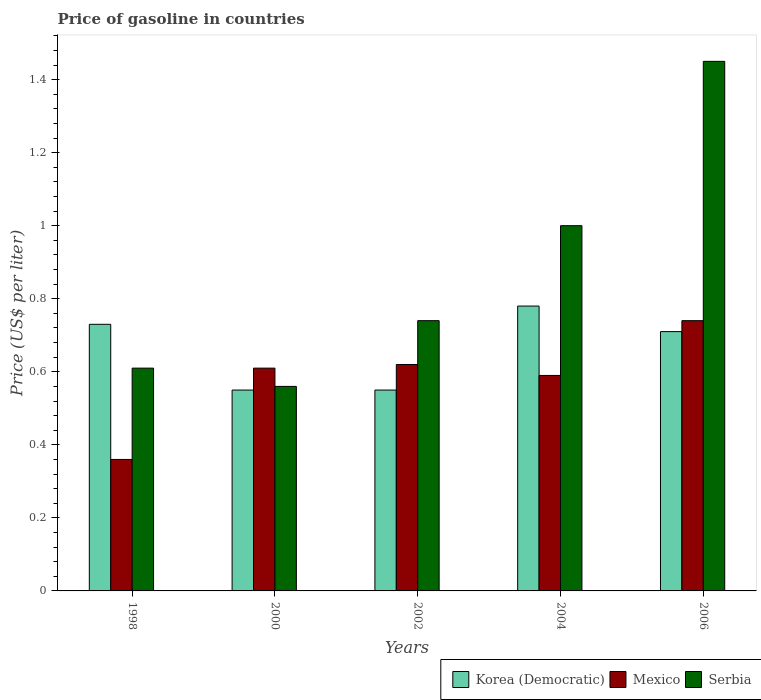How many groups of bars are there?
Make the answer very short. 5. Are the number of bars per tick equal to the number of legend labels?
Offer a terse response. Yes. Are the number of bars on each tick of the X-axis equal?
Provide a succinct answer. Yes. What is the price of gasoline in Mexico in 2002?
Give a very brief answer. 0.62. Across all years, what is the maximum price of gasoline in Korea (Democratic)?
Keep it short and to the point. 0.78. Across all years, what is the minimum price of gasoline in Serbia?
Provide a short and direct response. 0.56. In which year was the price of gasoline in Serbia minimum?
Provide a succinct answer. 2000. What is the total price of gasoline in Serbia in the graph?
Keep it short and to the point. 4.36. What is the difference between the price of gasoline in Mexico in 1998 and that in 2002?
Keep it short and to the point. -0.26. What is the difference between the price of gasoline in Mexico in 2006 and the price of gasoline in Korea (Democratic) in 2002?
Your response must be concise. 0.19. What is the average price of gasoline in Korea (Democratic) per year?
Provide a succinct answer. 0.66. In the year 2004, what is the difference between the price of gasoline in Korea (Democratic) and price of gasoline in Mexico?
Make the answer very short. 0.19. In how many years, is the price of gasoline in Mexico greater than 0.44 US$?
Give a very brief answer. 4. What is the ratio of the price of gasoline in Mexico in 2000 to that in 2006?
Provide a short and direct response. 0.82. Is the difference between the price of gasoline in Korea (Democratic) in 2004 and 2006 greater than the difference between the price of gasoline in Mexico in 2004 and 2006?
Ensure brevity in your answer.  Yes. What is the difference between the highest and the second highest price of gasoline in Serbia?
Ensure brevity in your answer.  0.45. What is the difference between the highest and the lowest price of gasoline in Mexico?
Provide a short and direct response. 0.38. In how many years, is the price of gasoline in Korea (Democratic) greater than the average price of gasoline in Korea (Democratic) taken over all years?
Provide a succinct answer. 3. What does the 1st bar from the left in 2000 represents?
Provide a short and direct response. Korea (Democratic). What does the 1st bar from the right in 2004 represents?
Offer a terse response. Serbia. Are all the bars in the graph horizontal?
Ensure brevity in your answer.  No. Are the values on the major ticks of Y-axis written in scientific E-notation?
Provide a succinct answer. No. Does the graph contain any zero values?
Offer a terse response. No. Where does the legend appear in the graph?
Your response must be concise. Bottom right. How are the legend labels stacked?
Provide a succinct answer. Horizontal. What is the title of the graph?
Provide a short and direct response. Price of gasoline in countries. What is the label or title of the X-axis?
Offer a terse response. Years. What is the label or title of the Y-axis?
Your response must be concise. Price (US$ per liter). What is the Price (US$ per liter) in Korea (Democratic) in 1998?
Ensure brevity in your answer.  0.73. What is the Price (US$ per liter) of Mexico in 1998?
Your response must be concise. 0.36. What is the Price (US$ per liter) of Serbia in 1998?
Give a very brief answer. 0.61. What is the Price (US$ per liter) in Korea (Democratic) in 2000?
Give a very brief answer. 0.55. What is the Price (US$ per liter) in Mexico in 2000?
Ensure brevity in your answer.  0.61. What is the Price (US$ per liter) in Serbia in 2000?
Your answer should be very brief. 0.56. What is the Price (US$ per liter) in Korea (Democratic) in 2002?
Ensure brevity in your answer.  0.55. What is the Price (US$ per liter) in Mexico in 2002?
Keep it short and to the point. 0.62. What is the Price (US$ per liter) of Serbia in 2002?
Offer a very short reply. 0.74. What is the Price (US$ per liter) of Korea (Democratic) in 2004?
Make the answer very short. 0.78. What is the Price (US$ per liter) of Mexico in 2004?
Your answer should be very brief. 0.59. What is the Price (US$ per liter) in Serbia in 2004?
Ensure brevity in your answer.  1. What is the Price (US$ per liter) in Korea (Democratic) in 2006?
Make the answer very short. 0.71. What is the Price (US$ per liter) of Mexico in 2006?
Provide a short and direct response. 0.74. What is the Price (US$ per liter) of Serbia in 2006?
Give a very brief answer. 1.45. Across all years, what is the maximum Price (US$ per liter) in Korea (Democratic)?
Keep it short and to the point. 0.78. Across all years, what is the maximum Price (US$ per liter) of Mexico?
Provide a succinct answer. 0.74. Across all years, what is the maximum Price (US$ per liter) in Serbia?
Offer a terse response. 1.45. Across all years, what is the minimum Price (US$ per liter) of Korea (Democratic)?
Ensure brevity in your answer.  0.55. Across all years, what is the minimum Price (US$ per liter) in Mexico?
Your response must be concise. 0.36. Across all years, what is the minimum Price (US$ per liter) of Serbia?
Provide a short and direct response. 0.56. What is the total Price (US$ per liter) of Korea (Democratic) in the graph?
Give a very brief answer. 3.32. What is the total Price (US$ per liter) of Mexico in the graph?
Give a very brief answer. 2.92. What is the total Price (US$ per liter) in Serbia in the graph?
Make the answer very short. 4.36. What is the difference between the Price (US$ per liter) of Korea (Democratic) in 1998 and that in 2000?
Provide a short and direct response. 0.18. What is the difference between the Price (US$ per liter) of Korea (Democratic) in 1998 and that in 2002?
Keep it short and to the point. 0.18. What is the difference between the Price (US$ per liter) in Mexico in 1998 and that in 2002?
Ensure brevity in your answer.  -0.26. What is the difference between the Price (US$ per liter) in Serbia in 1998 and that in 2002?
Ensure brevity in your answer.  -0.13. What is the difference between the Price (US$ per liter) in Mexico in 1998 and that in 2004?
Provide a succinct answer. -0.23. What is the difference between the Price (US$ per liter) of Serbia in 1998 and that in 2004?
Keep it short and to the point. -0.39. What is the difference between the Price (US$ per liter) of Mexico in 1998 and that in 2006?
Keep it short and to the point. -0.38. What is the difference between the Price (US$ per liter) in Serbia in 1998 and that in 2006?
Ensure brevity in your answer.  -0.84. What is the difference between the Price (US$ per liter) of Mexico in 2000 and that in 2002?
Offer a terse response. -0.01. What is the difference between the Price (US$ per liter) of Serbia in 2000 and that in 2002?
Offer a very short reply. -0.18. What is the difference between the Price (US$ per liter) of Korea (Democratic) in 2000 and that in 2004?
Provide a short and direct response. -0.23. What is the difference between the Price (US$ per liter) of Serbia in 2000 and that in 2004?
Offer a very short reply. -0.44. What is the difference between the Price (US$ per liter) of Korea (Democratic) in 2000 and that in 2006?
Provide a succinct answer. -0.16. What is the difference between the Price (US$ per liter) of Mexico in 2000 and that in 2006?
Your answer should be very brief. -0.13. What is the difference between the Price (US$ per liter) in Serbia in 2000 and that in 2006?
Give a very brief answer. -0.89. What is the difference between the Price (US$ per liter) in Korea (Democratic) in 2002 and that in 2004?
Your answer should be compact. -0.23. What is the difference between the Price (US$ per liter) in Serbia in 2002 and that in 2004?
Offer a very short reply. -0.26. What is the difference between the Price (US$ per liter) in Korea (Democratic) in 2002 and that in 2006?
Ensure brevity in your answer.  -0.16. What is the difference between the Price (US$ per liter) of Mexico in 2002 and that in 2006?
Make the answer very short. -0.12. What is the difference between the Price (US$ per liter) in Serbia in 2002 and that in 2006?
Offer a terse response. -0.71. What is the difference between the Price (US$ per liter) of Korea (Democratic) in 2004 and that in 2006?
Offer a terse response. 0.07. What is the difference between the Price (US$ per liter) in Serbia in 2004 and that in 2006?
Your response must be concise. -0.45. What is the difference between the Price (US$ per liter) of Korea (Democratic) in 1998 and the Price (US$ per liter) of Mexico in 2000?
Keep it short and to the point. 0.12. What is the difference between the Price (US$ per liter) of Korea (Democratic) in 1998 and the Price (US$ per liter) of Serbia in 2000?
Offer a terse response. 0.17. What is the difference between the Price (US$ per liter) in Mexico in 1998 and the Price (US$ per liter) in Serbia in 2000?
Provide a short and direct response. -0.2. What is the difference between the Price (US$ per liter) of Korea (Democratic) in 1998 and the Price (US$ per liter) of Mexico in 2002?
Your answer should be very brief. 0.11. What is the difference between the Price (US$ per liter) of Korea (Democratic) in 1998 and the Price (US$ per liter) of Serbia in 2002?
Keep it short and to the point. -0.01. What is the difference between the Price (US$ per liter) of Mexico in 1998 and the Price (US$ per liter) of Serbia in 2002?
Offer a terse response. -0.38. What is the difference between the Price (US$ per liter) in Korea (Democratic) in 1998 and the Price (US$ per liter) in Mexico in 2004?
Your answer should be very brief. 0.14. What is the difference between the Price (US$ per liter) of Korea (Democratic) in 1998 and the Price (US$ per liter) of Serbia in 2004?
Provide a succinct answer. -0.27. What is the difference between the Price (US$ per liter) of Mexico in 1998 and the Price (US$ per liter) of Serbia in 2004?
Offer a very short reply. -0.64. What is the difference between the Price (US$ per liter) in Korea (Democratic) in 1998 and the Price (US$ per liter) in Mexico in 2006?
Ensure brevity in your answer.  -0.01. What is the difference between the Price (US$ per liter) in Korea (Democratic) in 1998 and the Price (US$ per liter) in Serbia in 2006?
Your answer should be very brief. -0.72. What is the difference between the Price (US$ per liter) of Mexico in 1998 and the Price (US$ per liter) of Serbia in 2006?
Provide a short and direct response. -1.09. What is the difference between the Price (US$ per liter) of Korea (Democratic) in 2000 and the Price (US$ per liter) of Mexico in 2002?
Ensure brevity in your answer.  -0.07. What is the difference between the Price (US$ per liter) in Korea (Democratic) in 2000 and the Price (US$ per liter) in Serbia in 2002?
Keep it short and to the point. -0.19. What is the difference between the Price (US$ per liter) of Mexico in 2000 and the Price (US$ per liter) of Serbia in 2002?
Your answer should be very brief. -0.13. What is the difference between the Price (US$ per liter) in Korea (Democratic) in 2000 and the Price (US$ per liter) in Mexico in 2004?
Make the answer very short. -0.04. What is the difference between the Price (US$ per liter) in Korea (Democratic) in 2000 and the Price (US$ per liter) in Serbia in 2004?
Make the answer very short. -0.45. What is the difference between the Price (US$ per liter) of Mexico in 2000 and the Price (US$ per liter) of Serbia in 2004?
Offer a terse response. -0.39. What is the difference between the Price (US$ per liter) of Korea (Democratic) in 2000 and the Price (US$ per liter) of Mexico in 2006?
Offer a very short reply. -0.19. What is the difference between the Price (US$ per liter) in Korea (Democratic) in 2000 and the Price (US$ per liter) in Serbia in 2006?
Give a very brief answer. -0.9. What is the difference between the Price (US$ per liter) in Mexico in 2000 and the Price (US$ per liter) in Serbia in 2006?
Keep it short and to the point. -0.84. What is the difference between the Price (US$ per liter) in Korea (Democratic) in 2002 and the Price (US$ per liter) in Mexico in 2004?
Your answer should be compact. -0.04. What is the difference between the Price (US$ per liter) of Korea (Democratic) in 2002 and the Price (US$ per liter) of Serbia in 2004?
Provide a succinct answer. -0.45. What is the difference between the Price (US$ per liter) of Mexico in 2002 and the Price (US$ per liter) of Serbia in 2004?
Make the answer very short. -0.38. What is the difference between the Price (US$ per liter) in Korea (Democratic) in 2002 and the Price (US$ per liter) in Mexico in 2006?
Offer a very short reply. -0.19. What is the difference between the Price (US$ per liter) in Mexico in 2002 and the Price (US$ per liter) in Serbia in 2006?
Your answer should be compact. -0.83. What is the difference between the Price (US$ per liter) in Korea (Democratic) in 2004 and the Price (US$ per liter) in Mexico in 2006?
Offer a very short reply. 0.04. What is the difference between the Price (US$ per liter) of Korea (Democratic) in 2004 and the Price (US$ per liter) of Serbia in 2006?
Provide a short and direct response. -0.67. What is the difference between the Price (US$ per liter) of Mexico in 2004 and the Price (US$ per liter) of Serbia in 2006?
Provide a succinct answer. -0.86. What is the average Price (US$ per liter) of Korea (Democratic) per year?
Offer a terse response. 0.66. What is the average Price (US$ per liter) of Mexico per year?
Keep it short and to the point. 0.58. What is the average Price (US$ per liter) in Serbia per year?
Keep it short and to the point. 0.87. In the year 1998, what is the difference between the Price (US$ per liter) of Korea (Democratic) and Price (US$ per liter) of Mexico?
Provide a short and direct response. 0.37. In the year 1998, what is the difference between the Price (US$ per liter) in Korea (Democratic) and Price (US$ per liter) in Serbia?
Your response must be concise. 0.12. In the year 2000, what is the difference between the Price (US$ per liter) of Korea (Democratic) and Price (US$ per liter) of Mexico?
Offer a terse response. -0.06. In the year 2000, what is the difference between the Price (US$ per liter) of Korea (Democratic) and Price (US$ per liter) of Serbia?
Make the answer very short. -0.01. In the year 2002, what is the difference between the Price (US$ per liter) of Korea (Democratic) and Price (US$ per liter) of Mexico?
Offer a very short reply. -0.07. In the year 2002, what is the difference between the Price (US$ per liter) in Korea (Democratic) and Price (US$ per liter) in Serbia?
Ensure brevity in your answer.  -0.19. In the year 2002, what is the difference between the Price (US$ per liter) in Mexico and Price (US$ per liter) in Serbia?
Give a very brief answer. -0.12. In the year 2004, what is the difference between the Price (US$ per liter) in Korea (Democratic) and Price (US$ per liter) in Mexico?
Your answer should be very brief. 0.19. In the year 2004, what is the difference between the Price (US$ per liter) in Korea (Democratic) and Price (US$ per liter) in Serbia?
Your answer should be very brief. -0.22. In the year 2004, what is the difference between the Price (US$ per liter) of Mexico and Price (US$ per liter) of Serbia?
Your answer should be compact. -0.41. In the year 2006, what is the difference between the Price (US$ per liter) in Korea (Democratic) and Price (US$ per liter) in Mexico?
Your response must be concise. -0.03. In the year 2006, what is the difference between the Price (US$ per liter) of Korea (Democratic) and Price (US$ per liter) of Serbia?
Make the answer very short. -0.74. In the year 2006, what is the difference between the Price (US$ per liter) of Mexico and Price (US$ per liter) of Serbia?
Your answer should be very brief. -0.71. What is the ratio of the Price (US$ per liter) of Korea (Democratic) in 1998 to that in 2000?
Your answer should be very brief. 1.33. What is the ratio of the Price (US$ per liter) of Mexico in 1998 to that in 2000?
Give a very brief answer. 0.59. What is the ratio of the Price (US$ per liter) of Serbia in 1998 to that in 2000?
Offer a very short reply. 1.09. What is the ratio of the Price (US$ per liter) of Korea (Democratic) in 1998 to that in 2002?
Your answer should be very brief. 1.33. What is the ratio of the Price (US$ per liter) in Mexico in 1998 to that in 2002?
Your answer should be compact. 0.58. What is the ratio of the Price (US$ per liter) in Serbia in 1998 to that in 2002?
Keep it short and to the point. 0.82. What is the ratio of the Price (US$ per liter) in Korea (Democratic) in 1998 to that in 2004?
Keep it short and to the point. 0.94. What is the ratio of the Price (US$ per liter) in Mexico in 1998 to that in 2004?
Your response must be concise. 0.61. What is the ratio of the Price (US$ per liter) in Serbia in 1998 to that in 2004?
Ensure brevity in your answer.  0.61. What is the ratio of the Price (US$ per liter) in Korea (Democratic) in 1998 to that in 2006?
Your answer should be compact. 1.03. What is the ratio of the Price (US$ per liter) of Mexico in 1998 to that in 2006?
Give a very brief answer. 0.49. What is the ratio of the Price (US$ per liter) of Serbia in 1998 to that in 2006?
Keep it short and to the point. 0.42. What is the ratio of the Price (US$ per liter) of Mexico in 2000 to that in 2002?
Keep it short and to the point. 0.98. What is the ratio of the Price (US$ per liter) in Serbia in 2000 to that in 2002?
Offer a terse response. 0.76. What is the ratio of the Price (US$ per liter) in Korea (Democratic) in 2000 to that in 2004?
Provide a short and direct response. 0.71. What is the ratio of the Price (US$ per liter) of Mexico in 2000 to that in 2004?
Your answer should be very brief. 1.03. What is the ratio of the Price (US$ per liter) in Serbia in 2000 to that in 2004?
Your answer should be very brief. 0.56. What is the ratio of the Price (US$ per liter) of Korea (Democratic) in 2000 to that in 2006?
Offer a very short reply. 0.77. What is the ratio of the Price (US$ per liter) in Mexico in 2000 to that in 2006?
Ensure brevity in your answer.  0.82. What is the ratio of the Price (US$ per liter) in Serbia in 2000 to that in 2006?
Your answer should be compact. 0.39. What is the ratio of the Price (US$ per liter) in Korea (Democratic) in 2002 to that in 2004?
Your answer should be compact. 0.71. What is the ratio of the Price (US$ per liter) of Mexico in 2002 to that in 2004?
Provide a succinct answer. 1.05. What is the ratio of the Price (US$ per liter) of Serbia in 2002 to that in 2004?
Offer a terse response. 0.74. What is the ratio of the Price (US$ per liter) of Korea (Democratic) in 2002 to that in 2006?
Your answer should be very brief. 0.77. What is the ratio of the Price (US$ per liter) of Mexico in 2002 to that in 2006?
Ensure brevity in your answer.  0.84. What is the ratio of the Price (US$ per liter) in Serbia in 2002 to that in 2006?
Offer a very short reply. 0.51. What is the ratio of the Price (US$ per liter) in Korea (Democratic) in 2004 to that in 2006?
Your response must be concise. 1.1. What is the ratio of the Price (US$ per liter) of Mexico in 2004 to that in 2006?
Provide a succinct answer. 0.8. What is the ratio of the Price (US$ per liter) in Serbia in 2004 to that in 2006?
Offer a terse response. 0.69. What is the difference between the highest and the second highest Price (US$ per liter) in Mexico?
Ensure brevity in your answer.  0.12. What is the difference between the highest and the second highest Price (US$ per liter) of Serbia?
Provide a succinct answer. 0.45. What is the difference between the highest and the lowest Price (US$ per liter) in Korea (Democratic)?
Give a very brief answer. 0.23. What is the difference between the highest and the lowest Price (US$ per liter) of Mexico?
Your answer should be compact. 0.38. What is the difference between the highest and the lowest Price (US$ per liter) of Serbia?
Give a very brief answer. 0.89. 